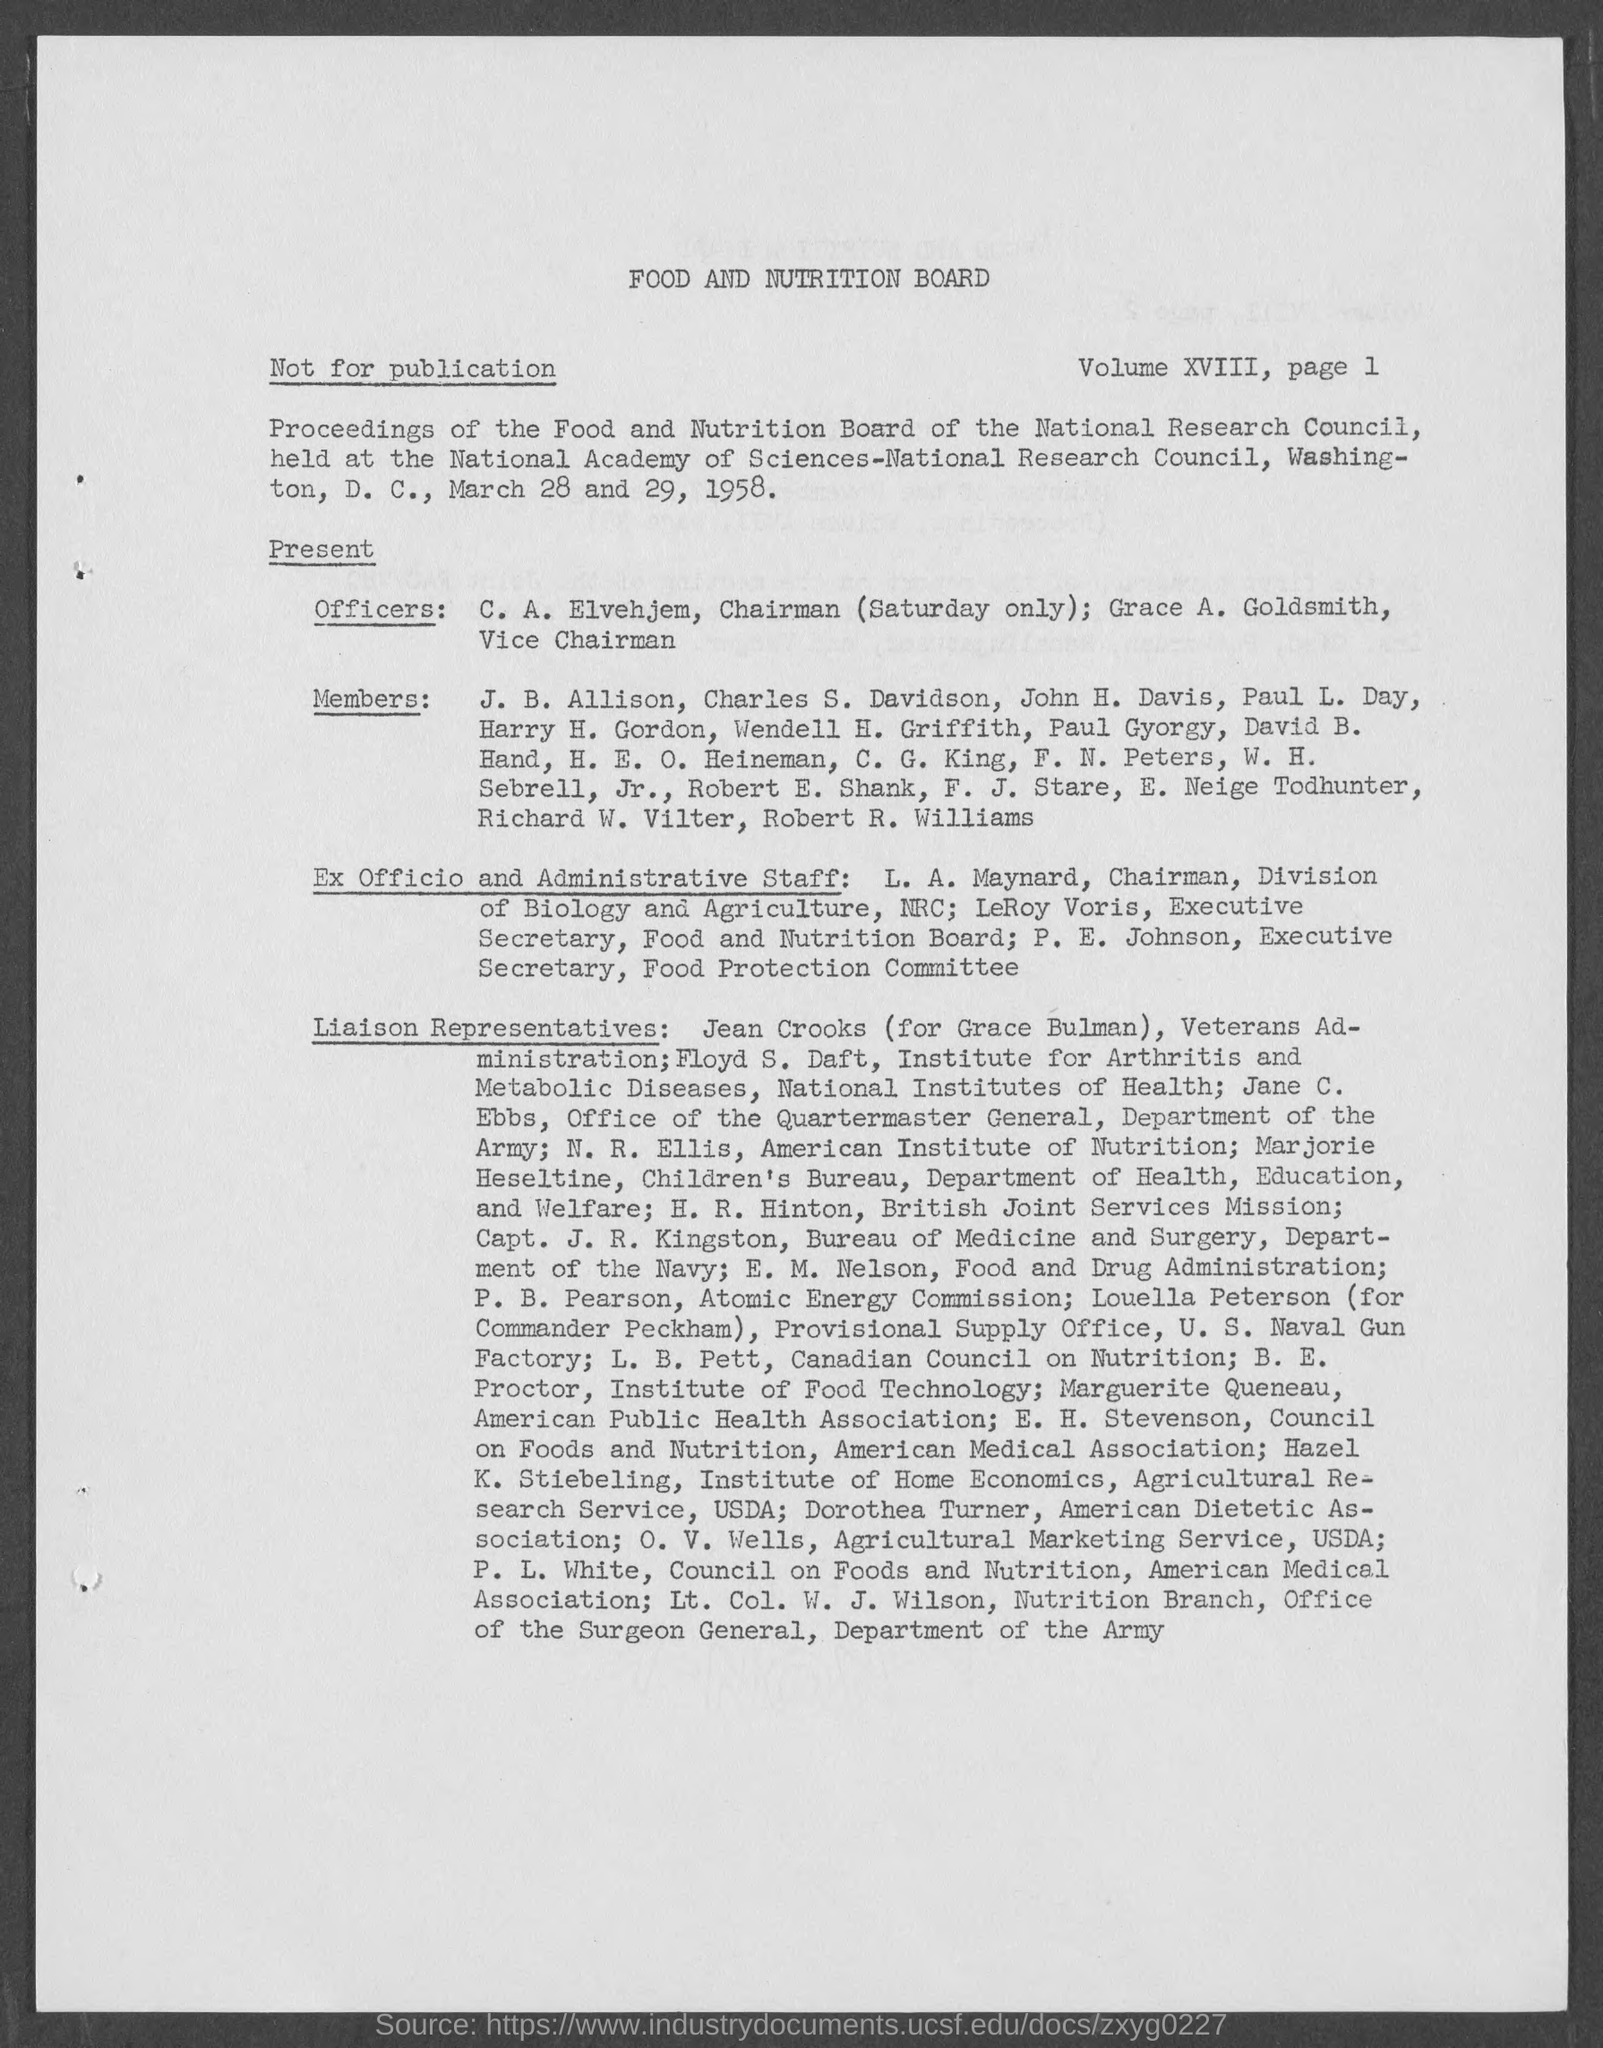Outline some significant characteristics in this image. The heading of the page is 'Food and Nutrition Board'. 